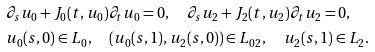Convert formula to latex. <formula><loc_0><loc_0><loc_500><loc_500>& \partial _ { s } u _ { 0 } + J _ { 0 } ( t , u _ { 0 } ) \partial _ { t } u _ { 0 } = 0 , \quad \partial _ { s } u _ { 2 } + J _ { 2 } ( t , u _ { 2 } ) \partial _ { t } u _ { 2 } = 0 , \\ & u _ { 0 } ( s , 0 ) \in L _ { 0 } , \quad ( u _ { 0 } ( s , 1 ) , u _ { 2 } ( s , 0 ) ) \in L _ { 0 2 } , \quad u _ { 2 } ( s , 1 ) \in L _ { 2 } .</formula> 